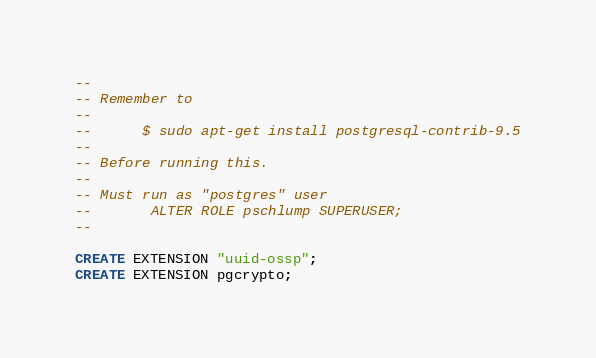<code> <loc_0><loc_0><loc_500><loc_500><_SQL_>
--
-- Remember to 
--
-- 		$ sudo apt-get install postgresql-contrib-9.5
--
-- Before running this.
--
-- Must run as "postgres" user
--       ALTER ROLE pschlump SUPERUSER;
--

CREATE EXTENSION "uuid-ossp";
CREATE EXTENSION pgcrypto;
</code> 